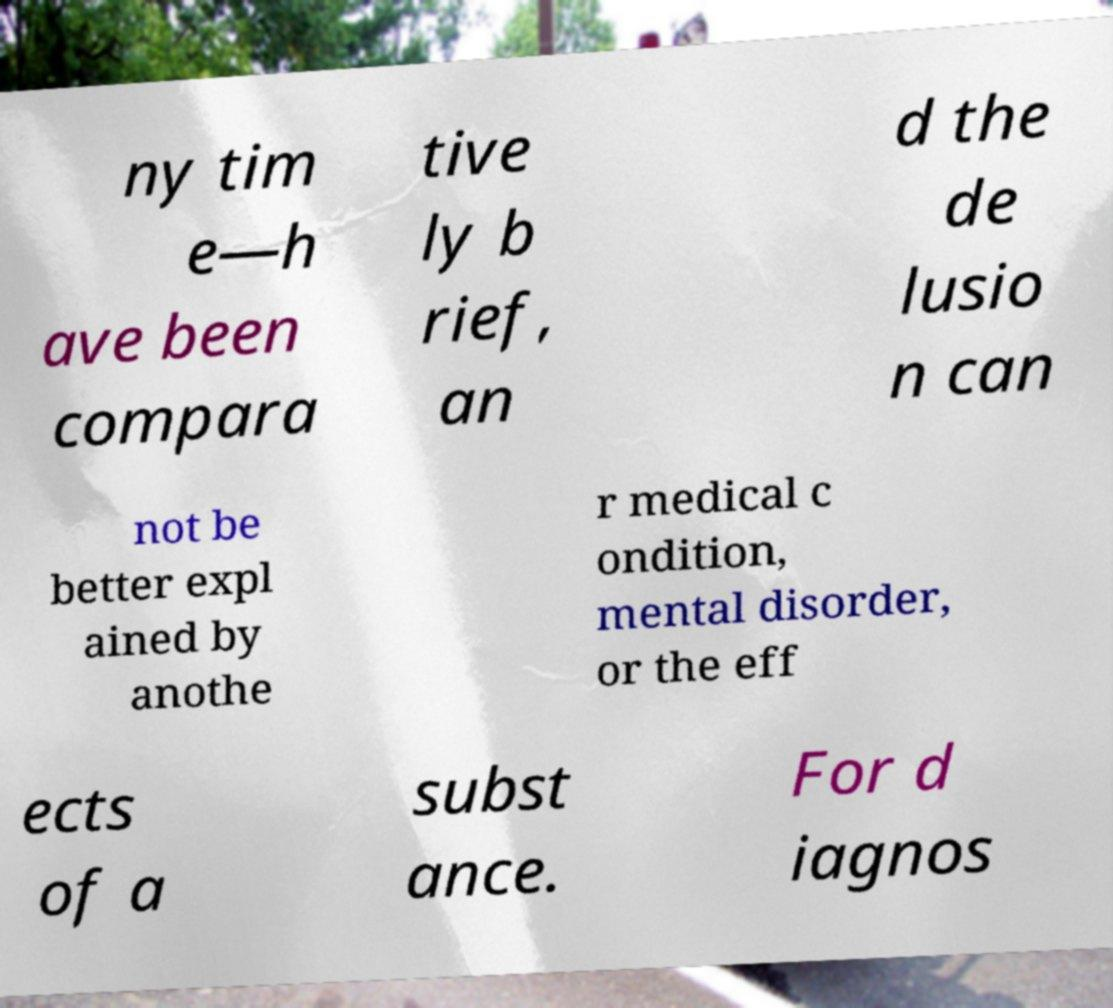I need the written content from this picture converted into text. Can you do that? ny tim e—h ave been compara tive ly b rief, an d the de lusio n can not be better expl ained by anothe r medical c ondition, mental disorder, or the eff ects of a subst ance. For d iagnos 